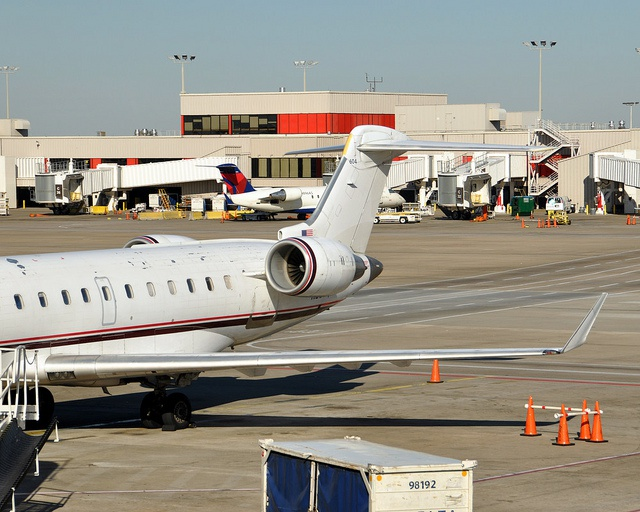Describe the objects in this image and their specific colors. I can see airplane in darkgray, lightgray, black, and gray tones, airplane in darkgray, ivory, gray, and black tones, and truck in darkgray, ivory, black, and gray tones in this image. 